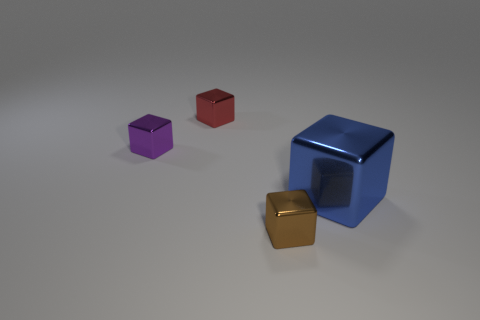Is the number of metal blocks in front of the purple metal block less than the number of big blue metal blocks?
Offer a terse response. No. There is a large block that is the same material as the tiny purple cube; what color is it?
Ensure brevity in your answer.  Blue. What is the size of the metallic cube to the right of the tiny brown shiny thing?
Your answer should be compact. Large. Do the blue cube and the tiny red cube have the same material?
Provide a short and direct response. Yes. Is there a block that is on the left side of the blue metallic block right of the tiny shiny cube behind the purple thing?
Ensure brevity in your answer.  Yes. The large object has what color?
Your response must be concise. Blue. There is a object that is on the right side of the brown thing; does it have the same shape as the brown metal thing?
Your answer should be compact. Yes. There is a metallic object that is on the left side of the tiny red metallic cube behind the metal block that is on the right side of the tiny brown metallic cube; what is its color?
Your answer should be very brief. Purple. Is there a large blue metal ball?
Keep it short and to the point. No. How many other objects are there of the same size as the blue metallic cube?
Your response must be concise. 0. 